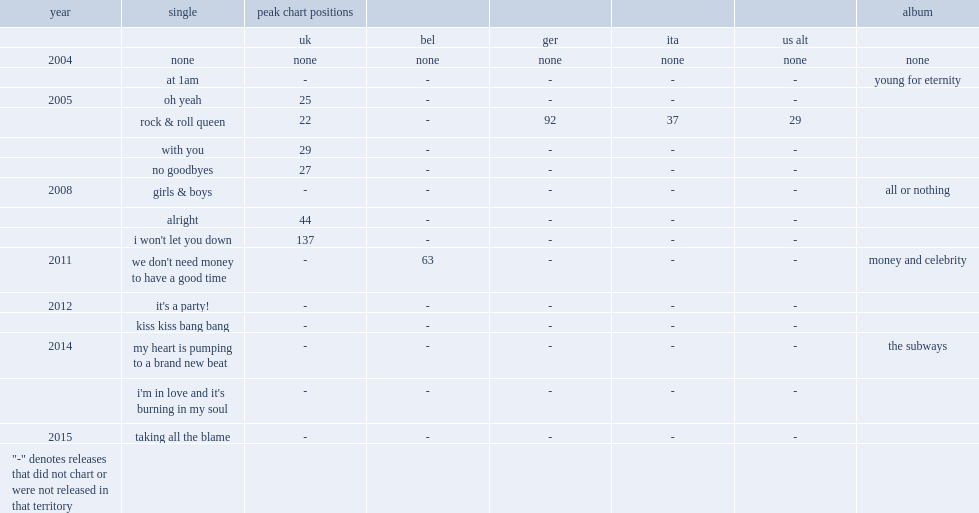What was the peak chart position on the uk of oh yeah? 25.0. 